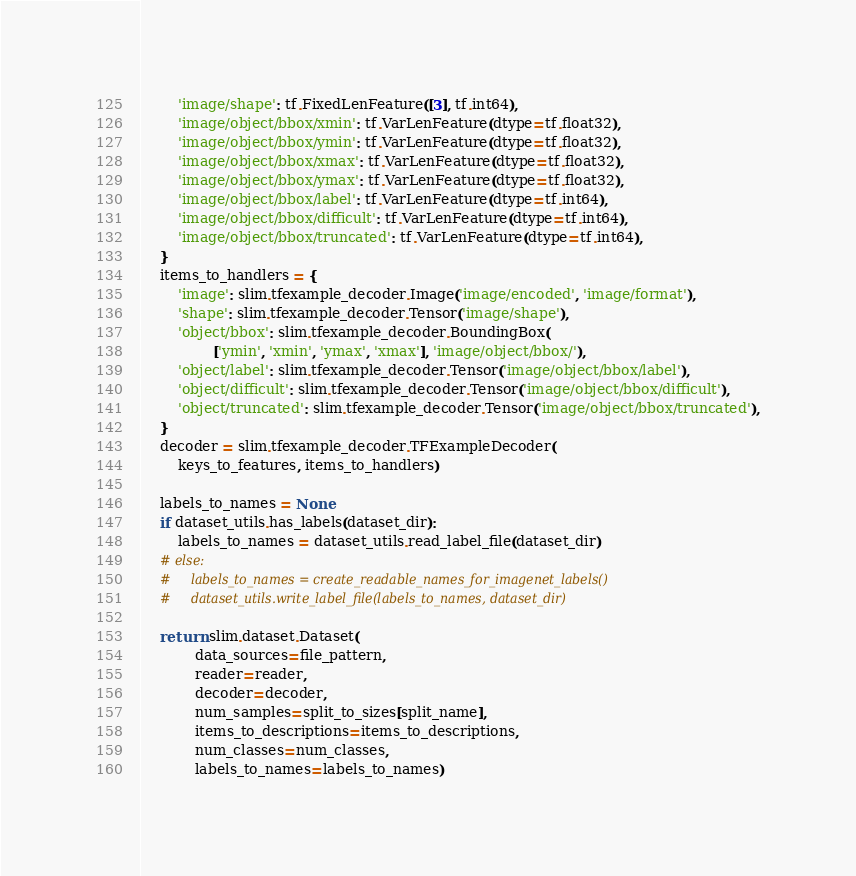Convert code to text. <code><loc_0><loc_0><loc_500><loc_500><_Python_>        'image/shape': tf.FixedLenFeature([3], tf.int64),
        'image/object/bbox/xmin': tf.VarLenFeature(dtype=tf.float32),
        'image/object/bbox/ymin': tf.VarLenFeature(dtype=tf.float32),
        'image/object/bbox/xmax': tf.VarLenFeature(dtype=tf.float32),
        'image/object/bbox/ymax': tf.VarLenFeature(dtype=tf.float32),
        'image/object/bbox/label': tf.VarLenFeature(dtype=tf.int64),
        'image/object/bbox/difficult': tf.VarLenFeature(dtype=tf.int64),
        'image/object/bbox/truncated': tf.VarLenFeature(dtype=tf.int64),
    }
    items_to_handlers = {
        'image': slim.tfexample_decoder.Image('image/encoded', 'image/format'),
        'shape': slim.tfexample_decoder.Tensor('image/shape'),
        'object/bbox': slim.tfexample_decoder.BoundingBox(
                ['ymin', 'xmin', 'ymax', 'xmax'], 'image/object/bbox/'),
        'object/label': slim.tfexample_decoder.Tensor('image/object/bbox/label'),
        'object/difficult': slim.tfexample_decoder.Tensor('image/object/bbox/difficult'),
        'object/truncated': slim.tfexample_decoder.Tensor('image/object/bbox/truncated'),
    }
    decoder = slim.tfexample_decoder.TFExampleDecoder(
        keys_to_features, items_to_handlers)

    labels_to_names = None
    if dataset_utils.has_labels(dataset_dir):
        labels_to_names = dataset_utils.read_label_file(dataset_dir)
    # else:
    #     labels_to_names = create_readable_names_for_imagenet_labels()
    #     dataset_utils.write_label_file(labels_to_names, dataset_dir)

    return slim.dataset.Dataset(
            data_sources=file_pattern,
            reader=reader,
            decoder=decoder,
            num_samples=split_to_sizes[split_name],
            items_to_descriptions=items_to_descriptions,
            num_classes=num_classes,
            labels_to_names=labels_to_names)
</code> 